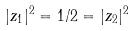Convert formula to latex. <formula><loc_0><loc_0><loc_500><loc_500>| z _ { 1 } | ^ { 2 } = 1 / 2 = | z _ { 2 } | ^ { 2 }</formula> 